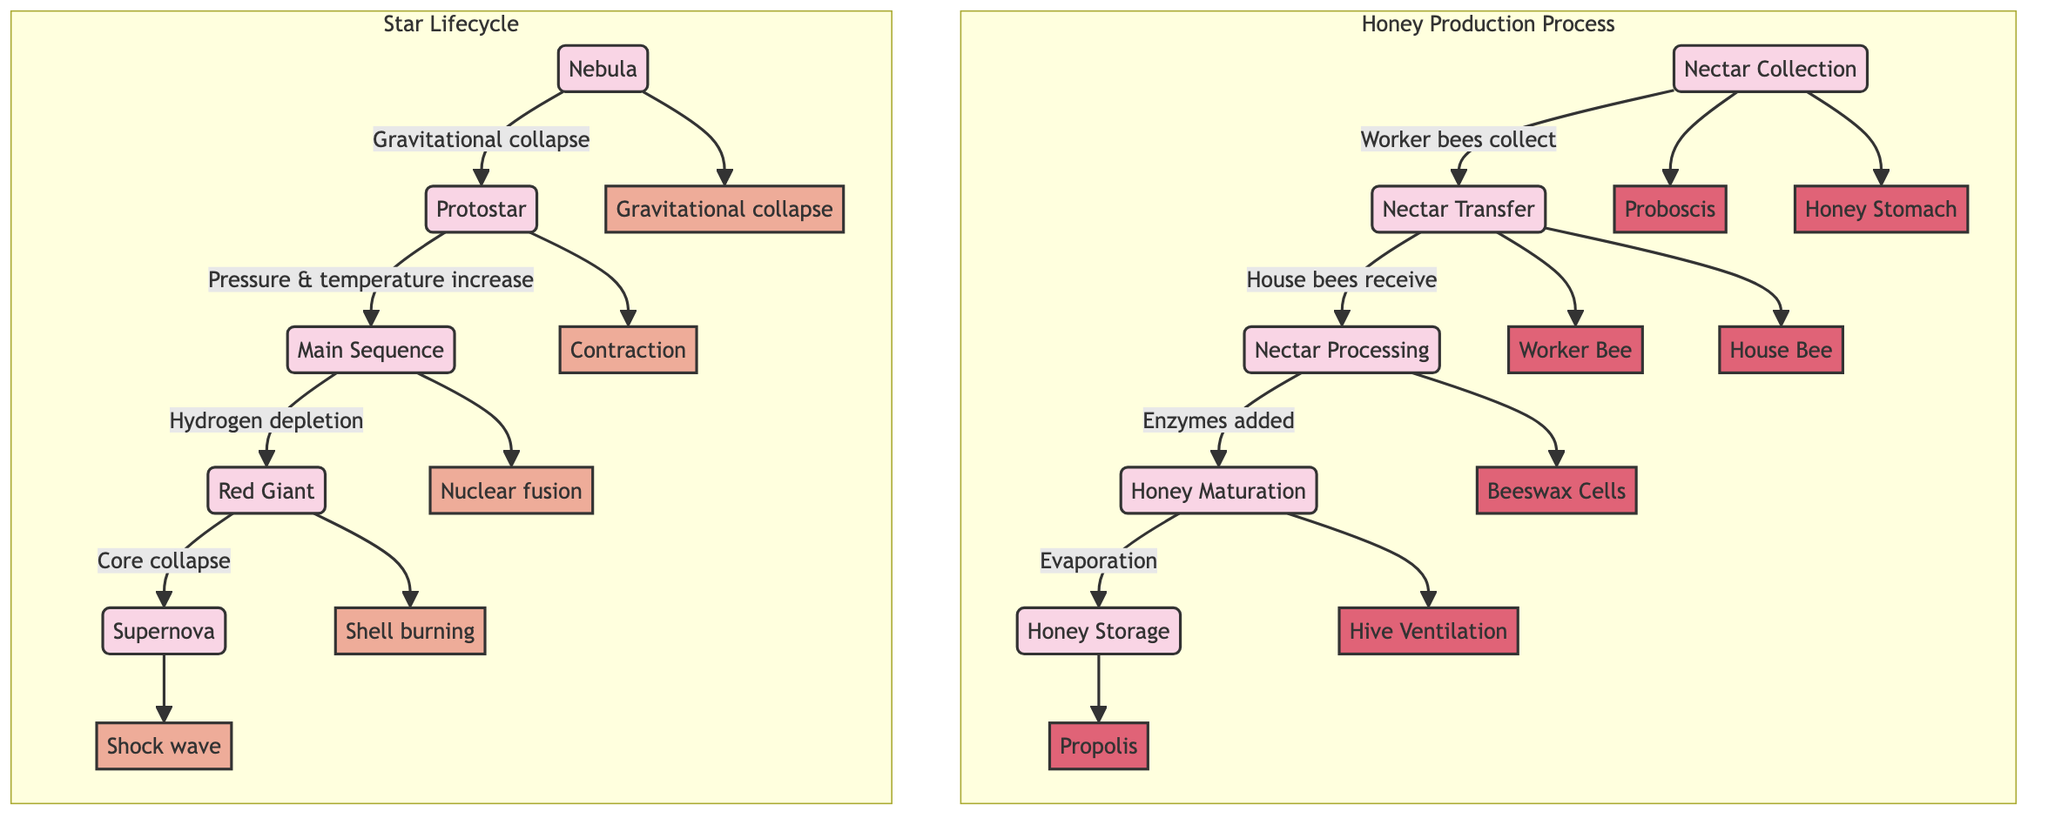What is the first stage of honey production? The diagram indicates that the first stage of honey production is "Nectar Collection." This is the starting point in the flow, leading to other stages.
Answer: Nectar Collection How many main stages are there in the honey production process? The diagram shows five distinct stages in the honey production process: Nectar Collection, Nectar Transfer, Nectar Processing, Honey Maturation, and Honey Storage. By counting these stages, we find the total.
Answer: 5 What are the two structures involved in nectar collection? The diagram identifies "Proboscis" and "Honey Stomach" as the two anatomical structures used during the nectar collection stage. These structures are directly linked to "Nectar Collection."
Answer: Proboscis and Honey Stomach What process follows the protostar in the star lifecycle? The diagram outlines that the stage following "Protostar" is "Main Sequence." This relationship can be tracked by following the directional arrows from one stage to the next.
Answer: Main Sequence Which physical process is associated with the red giant stage? The diagram indicates that "Shell burning" is the physical process that occurs during the "Red Giant" stage. This can be identified by looking at the process connected to that stage.
Answer: Shell burning What is the final stage of a star's lifecycle according to the diagram? Following the sequence in the diagram, the last stage of a star's lifecycle is "Supernova." It is the endpoint in the flow of the star lifecycle stages.
Answer: Supernova How does nectar transformation occur in honey production? According to the diagram, the transformation occurs during the "Nectar Processing" stage where enzymes are added. This is a key step linking the transfer and maturation phases.
Answer: Enzymes added What is the sequence of stages from nebula to supernova? The sequence can be traced as follows: Nebula → Protostar → Main Sequence → Red Giant → Supernova. By following the arrows in the diagram, we establish this order.
Answer: Nebula, Protostar, Main Sequence, Red Giant, Supernova What additional process is included in nectar maturation? The diagram specifies that "Evaporation" is the additional process involved in "Honey Maturation." This describes the physical change that occurs during this stage.
Answer: Evaporation 